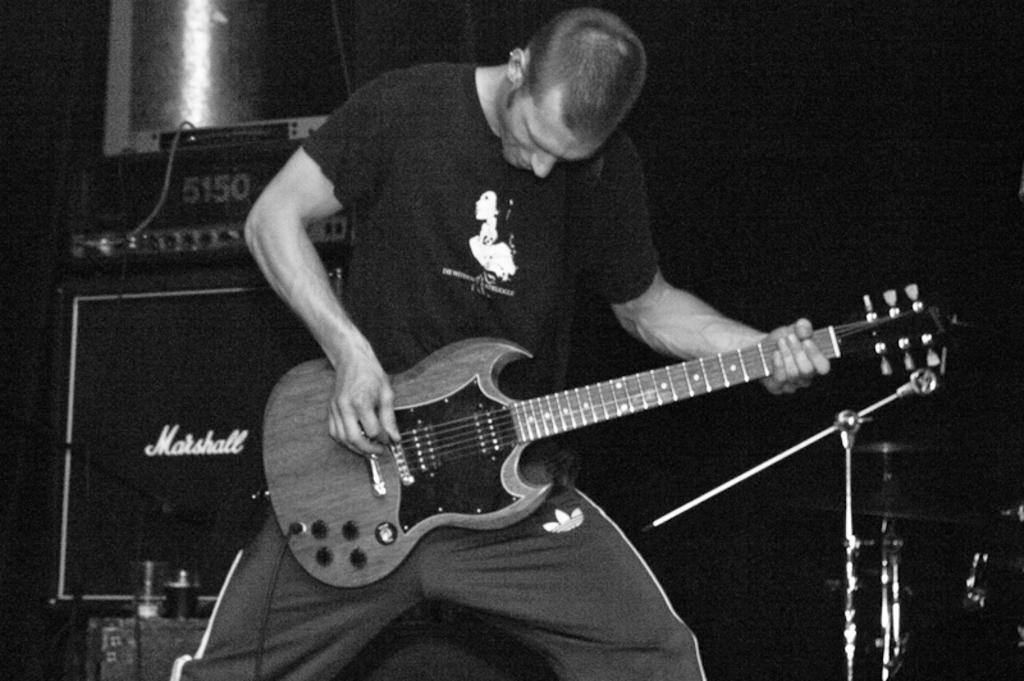What is the main subject of the image? The main subject of the image is a man. What is the man doing in the image? The man is standing and playing a guitar. How is the guitar being held in the image? The guitar is held in the man's hands. What type of mine can be seen in the background of the image? There is no mine present in the image; it features a man playing a guitar. How many doors are visible in the image? There are no doors visible in the image. 